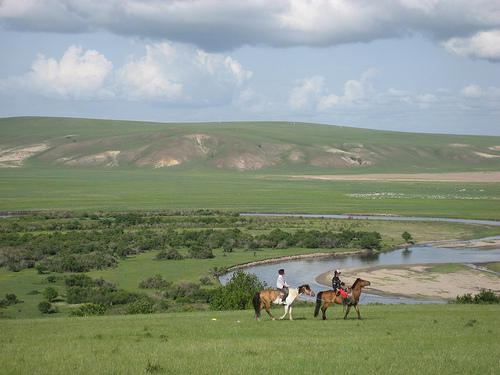Question: what is the ground made of?
Choices:
A. Grass.
B. Dirt.
C. Clay.
D. Asphalt.
Answer with the letter. Answer: A Question: what are the men riding?
Choices:
A. Motorcycles.
B. Horse.
C. Mopeds.
D. Wave Runners.
Answer with the letter. Answer: B Question: how many horse are there?
Choices:
A. One.
B. Three.
C. Two.
D. Four.
Answer with the letter. Answer: C Question: what color are the horse?
Choices:
A. Black.
B. Yellow.
C. Dark green.
D. Brown.
Answer with the letter. Answer: D Question: why is it so bright?
Choices:
A. Spot lights.
B. Sunny.
C. Lamps.
D. Fire.
Answer with the letter. Answer: B 